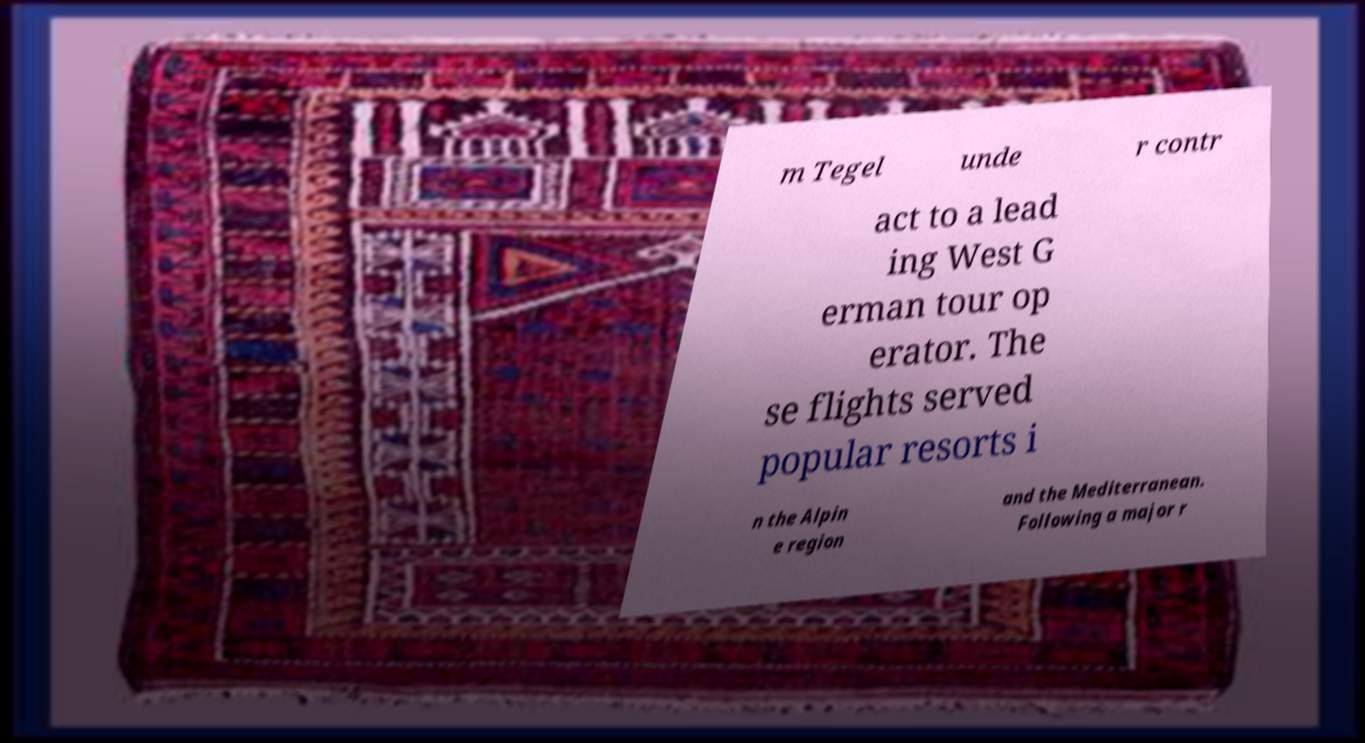For documentation purposes, I need the text within this image transcribed. Could you provide that? m Tegel unde r contr act to a lead ing West G erman tour op erator. The se flights served popular resorts i n the Alpin e region and the Mediterranean. Following a major r 